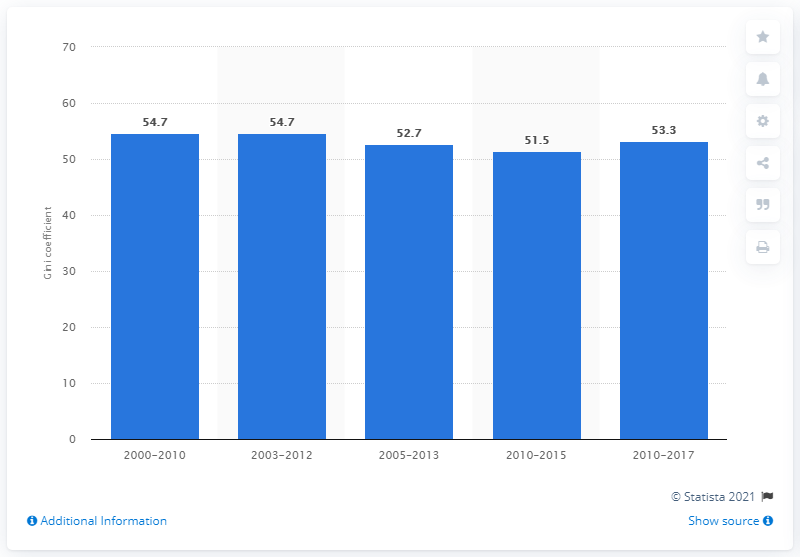Point out several critical features in this image. The Gini coefficient for Brazil in 2017 was 53.3, indicating a moderate level of income inequality in the country. 